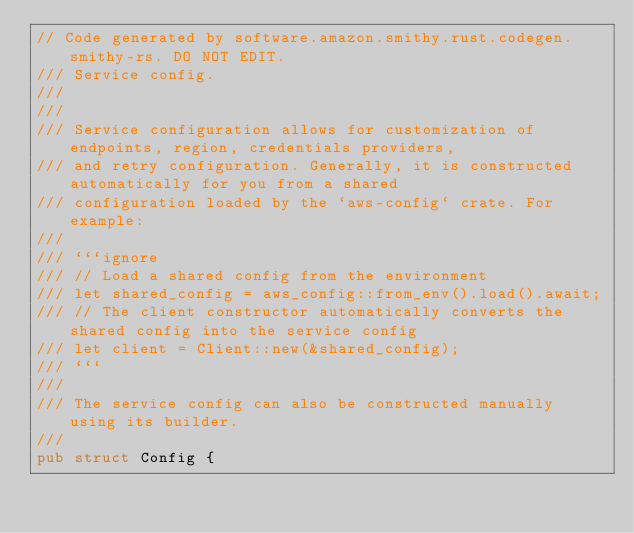<code> <loc_0><loc_0><loc_500><loc_500><_Rust_>// Code generated by software.amazon.smithy.rust.codegen.smithy-rs. DO NOT EDIT.
/// Service config.
///
///
/// Service configuration allows for customization of endpoints, region, credentials providers,
/// and retry configuration. Generally, it is constructed automatically for you from a shared
/// configuration loaded by the `aws-config` crate. For example:
///
/// ```ignore
/// // Load a shared config from the environment
/// let shared_config = aws_config::from_env().load().await;
/// // The client constructor automatically converts the shared config into the service config
/// let client = Client::new(&shared_config);
/// ```
///
/// The service config can also be constructed manually using its builder.
///
pub struct Config {</code> 